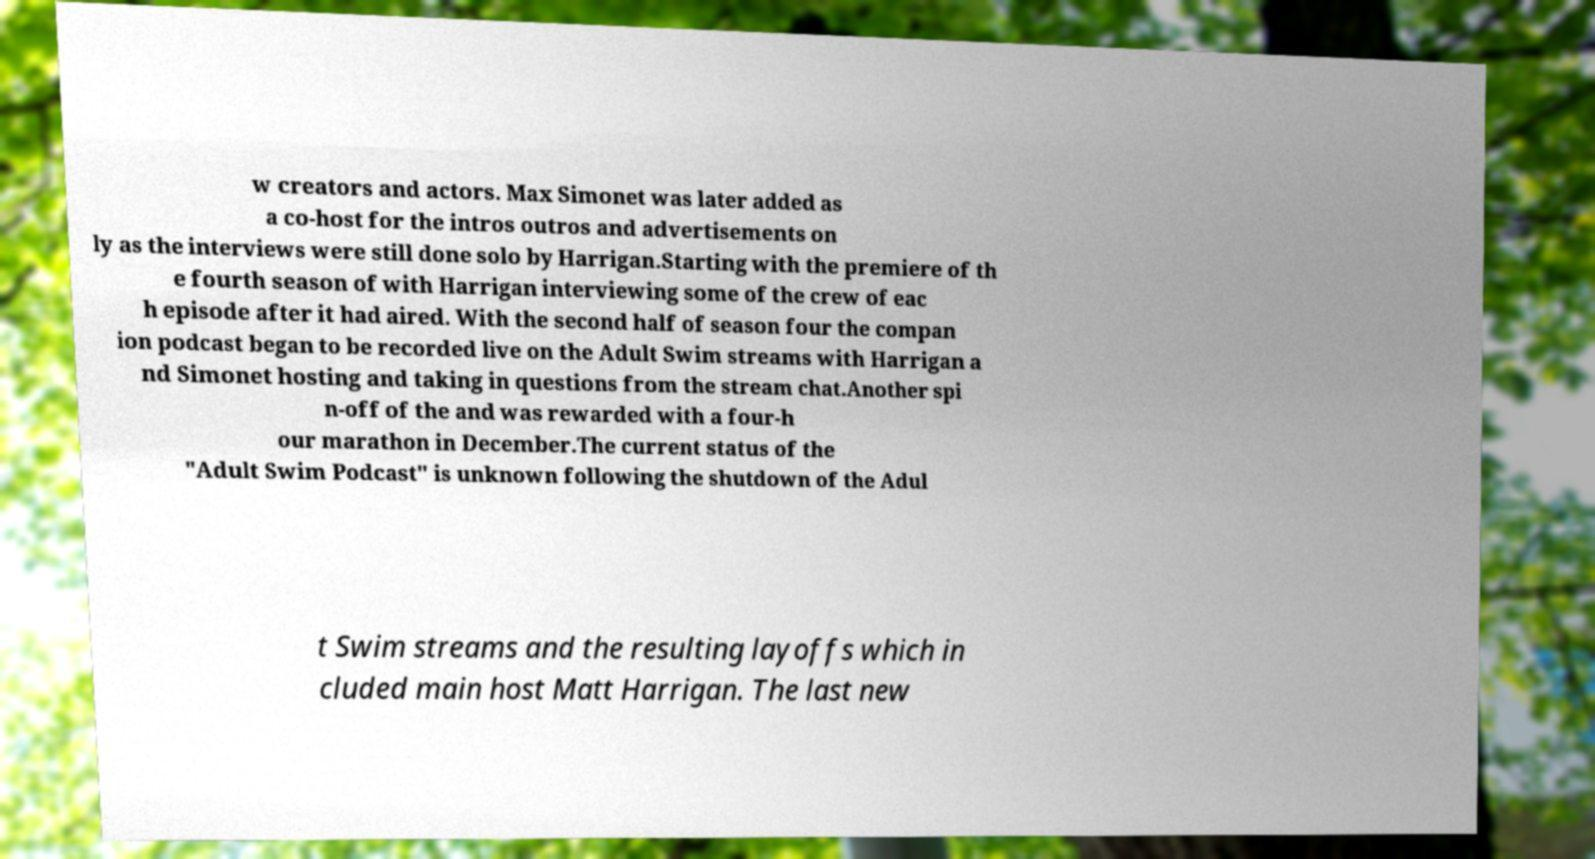For documentation purposes, I need the text within this image transcribed. Could you provide that? w creators and actors. Max Simonet was later added as a co-host for the intros outros and advertisements on ly as the interviews were still done solo by Harrigan.Starting with the premiere of th e fourth season of with Harrigan interviewing some of the crew of eac h episode after it had aired. With the second half of season four the compan ion podcast began to be recorded live on the Adult Swim streams with Harrigan a nd Simonet hosting and taking in questions from the stream chat.Another spi n-off of the and was rewarded with a four-h our marathon in December.The current status of the "Adult Swim Podcast" is unknown following the shutdown of the Adul t Swim streams and the resulting layoffs which in cluded main host Matt Harrigan. The last new 